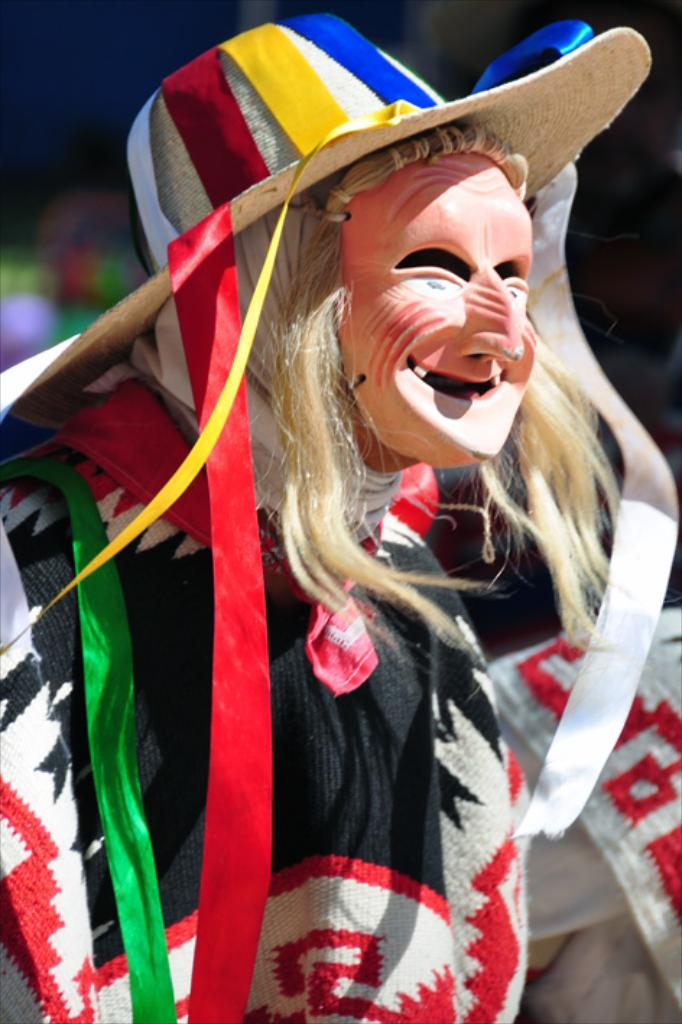Who is present in the image? There is a person in the image. What is the person wearing on their face? The person is wearing a mask. What type of headwear is the person wearing? The person is wearing a cap. Can you describe the background of the image? The background of the image is blurry. What type of nerve is responsible for the person's behavior in the image? There is no information about the person's behavior or any specific nerve in the image. 